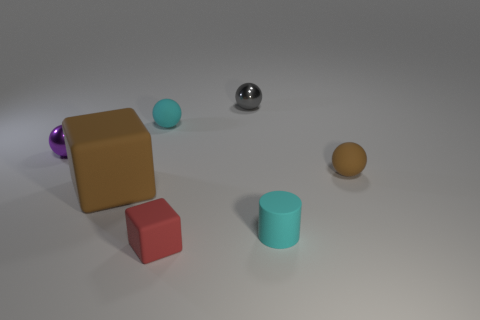Is the number of small cylinders that are to the right of the gray metallic thing less than the number of matte things on the left side of the tiny red block?
Your answer should be very brief. Yes. There is a cyan thing that is made of the same material as the small cyan cylinder; what shape is it?
Offer a terse response. Sphere. There is a brown thing to the left of the shiny sphere that is to the right of the matte sphere that is left of the small red matte block; what is its size?
Provide a short and direct response. Large. Is the number of large brown objects greater than the number of tiny matte spheres?
Your answer should be very brief. No. There is a small rubber sphere right of the cyan matte ball; is it the same color as the large rubber block in front of the cyan sphere?
Your answer should be very brief. Yes. Is the material of the small object that is in front of the tiny cyan cylinder the same as the tiny purple object behind the big brown rubber block?
Ensure brevity in your answer.  No. How many cubes have the same size as the cyan cylinder?
Offer a terse response. 1. Is the number of tiny cylinders less than the number of tiny yellow metal balls?
Give a very brief answer. No. The object that is in front of the cyan object to the right of the gray thing is what shape?
Your answer should be very brief. Cube. There is a gray metal object that is the same size as the red rubber object; what shape is it?
Provide a short and direct response. Sphere. 